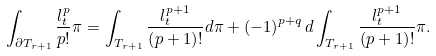Convert formula to latex. <formula><loc_0><loc_0><loc_500><loc_500>\int _ { \partial T _ { r + 1 } } \frac { l _ { t } ^ { p } } { p ! } \pi = \int _ { T _ { r + 1 } } \frac { l _ { t } ^ { p + 1 } } { \left ( p + 1 \right ) ! } d \pi + \left ( - 1 \right ) ^ { p + q } d \int _ { T _ { r + 1 } } \frac { l _ { t } ^ { p + 1 } } { \left ( p + 1 \right ) ! } \pi .</formula> 